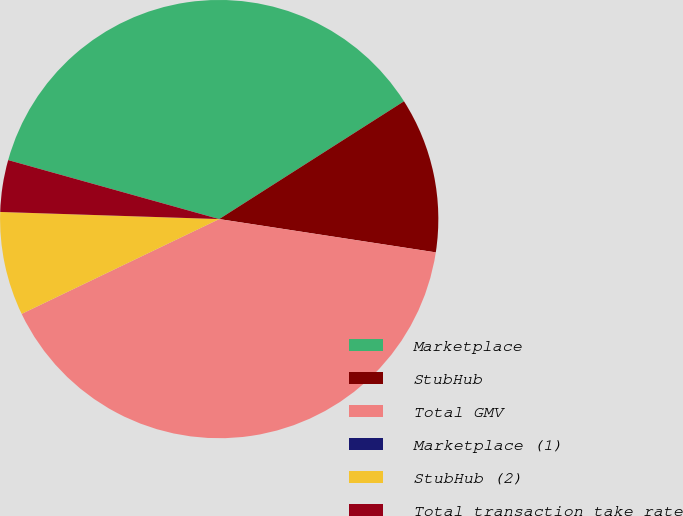Convert chart. <chart><loc_0><loc_0><loc_500><loc_500><pie_chart><fcel>Marketplace<fcel>StubHub<fcel>Total GMV<fcel>Marketplace (1)<fcel>StubHub (2)<fcel>Total transaction take rate<nl><fcel>36.63%<fcel>11.46%<fcel>40.45%<fcel>0.0%<fcel>7.64%<fcel>3.82%<nl></chart> 